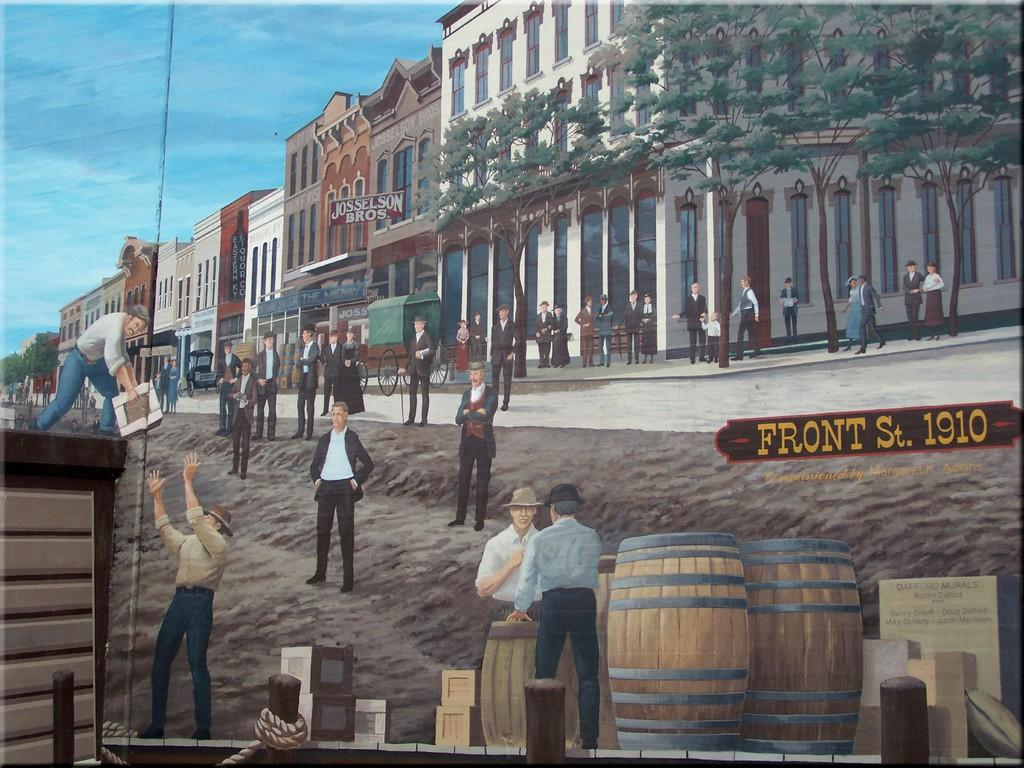<image>
Give a short and clear explanation of the subsequent image. Painting of people working in a city and the label Front St. 1910 on it. 